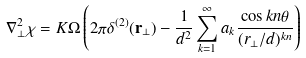Convert formula to latex. <formula><loc_0><loc_0><loc_500><loc_500>\nabla _ { \perp } ^ { 2 } \chi = K \Omega \left ( 2 \pi \delta ^ { ( 2 ) } ( { \mathbf r } _ { \perp } ) - \frac { 1 } { d ^ { 2 } } \sum _ { k = 1 } ^ { \infty } a _ { k } \frac { \cos { k n \theta } } { ( r _ { \perp } / d ) ^ { k n } } \right )</formula> 